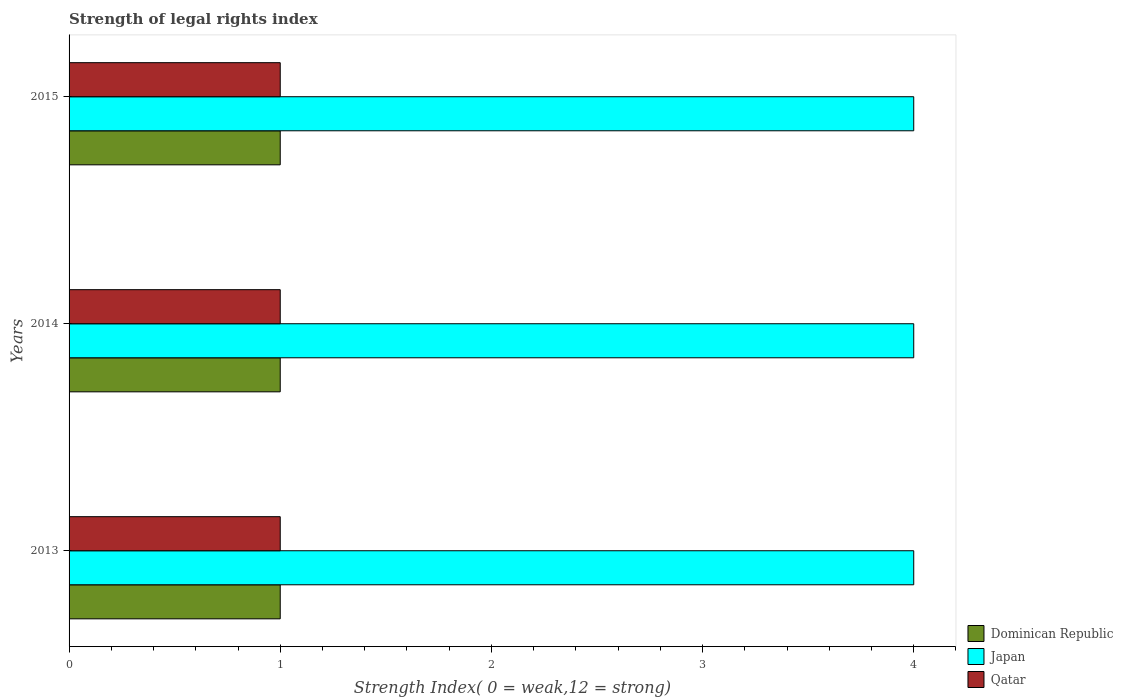How many different coloured bars are there?
Your response must be concise. 3. How many groups of bars are there?
Offer a terse response. 3. Are the number of bars on each tick of the Y-axis equal?
Offer a terse response. Yes. How many bars are there on the 2nd tick from the top?
Provide a short and direct response. 3. What is the label of the 1st group of bars from the top?
Your answer should be very brief. 2015. In how many cases, is the number of bars for a given year not equal to the number of legend labels?
Your answer should be compact. 0. What is the strength index in Dominican Republic in 2015?
Provide a succinct answer. 1. Across all years, what is the maximum strength index in Qatar?
Your response must be concise. 1. Across all years, what is the minimum strength index in Dominican Republic?
Your answer should be very brief. 1. In which year was the strength index in Dominican Republic minimum?
Offer a terse response. 2013. What is the total strength index in Japan in the graph?
Your answer should be compact. 12. What is the difference between the strength index in Dominican Republic in 2013 and the strength index in Japan in 2015?
Keep it short and to the point. -3. In how many years, is the strength index in Japan greater than 3.2 ?
Your answer should be compact. 3. What is the ratio of the strength index in Qatar in 2013 to that in 2014?
Keep it short and to the point. 1. What does the 1st bar from the top in 2013 represents?
Provide a succinct answer. Qatar. What does the 1st bar from the bottom in 2015 represents?
Give a very brief answer. Dominican Republic. Is it the case that in every year, the sum of the strength index in Qatar and strength index in Japan is greater than the strength index in Dominican Republic?
Ensure brevity in your answer.  Yes. How many bars are there?
Make the answer very short. 9. Are all the bars in the graph horizontal?
Give a very brief answer. Yes. What is the difference between two consecutive major ticks on the X-axis?
Ensure brevity in your answer.  1. Are the values on the major ticks of X-axis written in scientific E-notation?
Your response must be concise. No. Does the graph contain any zero values?
Provide a short and direct response. No. Does the graph contain grids?
Your response must be concise. No. How are the legend labels stacked?
Offer a terse response. Vertical. What is the title of the graph?
Give a very brief answer. Strength of legal rights index. What is the label or title of the X-axis?
Give a very brief answer. Strength Index( 0 = weak,12 = strong). What is the Strength Index( 0 = weak,12 = strong) in Japan in 2013?
Your answer should be compact. 4. What is the Strength Index( 0 = weak,12 = strong) of Qatar in 2014?
Offer a very short reply. 1. What is the Strength Index( 0 = weak,12 = strong) of Dominican Republic in 2015?
Your answer should be compact. 1. What is the Strength Index( 0 = weak,12 = strong) in Japan in 2015?
Give a very brief answer. 4. What is the Strength Index( 0 = weak,12 = strong) of Qatar in 2015?
Give a very brief answer. 1. Across all years, what is the maximum Strength Index( 0 = weak,12 = strong) of Dominican Republic?
Make the answer very short. 1. Across all years, what is the maximum Strength Index( 0 = weak,12 = strong) of Japan?
Provide a short and direct response. 4. Across all years, what is the maximum Strength Index( 0 = weak,12 = strong) of Qatar?
Provide a short and direct response. 1. Across all years, what is the minimum Strength Index( 0 = weak,12 = strong) in Dominican Republic?
Ensure brevity in your answer.  1. Across all years, what is the minimum Strength Index( 0 = weak,12 = strong) in Japan?
Keep it short and to the point. 4. Across all years, what is the minimum Strength Index( 0 = weak,12 = strong) of Qatar?
Provide a succinct answer. 1. What is the total Strength Index( 0 = weak,12 = strong) of Japan in the graph?
Ensure brevity in your answer.  12. What is the total Strength Index( 0 = weak,12 = strong) in Qatar in the graph?
Ensure brevity in your answer.  3. What is the difference between the Strength Index( 0 = weak,12 = strong) of Japan in 2013 and that in 2014?
Provide a short and direct response. 0. What is the difference between the Strength Index( 0 = weak,12 = strong) of Dominican Republic in 2013 and that in 2015?
Keep it short and to the point. 0. What is the difference between the Strength Index( 0 = weak,12 = strong) in Japan in 2014 and that in 2015?
Your answer should be very brief. 0. What is the difference between the Strength Index( 0 = weak,12 = strong) in Dominican Republic in 2013 and the Strength Index( 0 = weak,12 = strong) in Japan in 2014?
Keep it short and to the point. -3. What is the difference between the Strength Index( 0 = weak,12 = strong) in Dominican Republic in 2013 and the Strength Index( 0 = weak,12 = strong) in Japan in 2015?
Ensure brevity in your answer.  -3. What is the difference between the Strength Index( 0 = weak,12 = strong) in Dominican Republic in 2013 and the Strength Index( 0 = weak,12 = strong) in Qatar in 2015?
Ensure brevity in your answer.  0. What is the difference between the Strength Index( 0 = weak,12 = strong) in Japan in 2013 and the Strength Index( 0 = weak,12 = strong) in Qatar in 2015?
Provide a short and direct response. 3. What is the difference between the Strength Index( 0 = weak,12 = strong) of Dominican Republic in 2014 and the Strength Index( 0 = weak,12 = strong) of Japan in 2015?
Your response must be concise. -3. What is the difference between the Strength Index( 0 = weak,12 = strong) of Dominican Republic in 2014 and the Strength Index( 0 = weak,12 = strong) of Qatar in 2015?
Provide a short and direct response. 0. In the year 2013, what is the difference between the Strength Index( 0 = weak,12 = strong) in Dominican Republic and Strength Index( 0 = weak,12 = strong) in Qatar?
Provide a succinct answer. 0. In the year 2013, what is the difference between the Strength Index( 0 = weak,12 = strong) of Japan and Strength Index( 0 = weak,12 = strong) of Qatar?
Your answer should be compact. 3. In the year 2014, what is the difference between the Strength Index( 0 = weak,12 = strong) of Dominican Republic and Strength Index( 0 = weak,12 = strong) of Japan?
Ensure brevity in your answer.  -3. In the year 2014, what is the difference between the Strength Index( 0 = weak,12 = strong) of Japan and Strength Index( 0 = weak,12 = strong) of Qatar?
Make the answer very short. 3. What is the ratio of the Strength Index( 0 = weak,12 = strong) in Dominican Republic in 2013 to that in 2015?
Offer a terse response. 1. What is the ratio of the Strength Index( 0 = weak,12 = strong) in Qatar in 2013 to that in 2015?
Keep it short and to the point. 1. What is the ratio of the Strength Index( 0 = weak,12 = strong) in Japan in 2014 to that in 2015?
Ensure brevity in your answer.  1. What is the difference between the highest and the second highest Strength Index( 0 = weak,12 = strong) of Dominican Republic?
Provide a short and direct response. 0. What is the difference between the highest and the lowest Strength Index( 0 = weak,12 = strong) in Japan?
Offer a terse response. 0. 